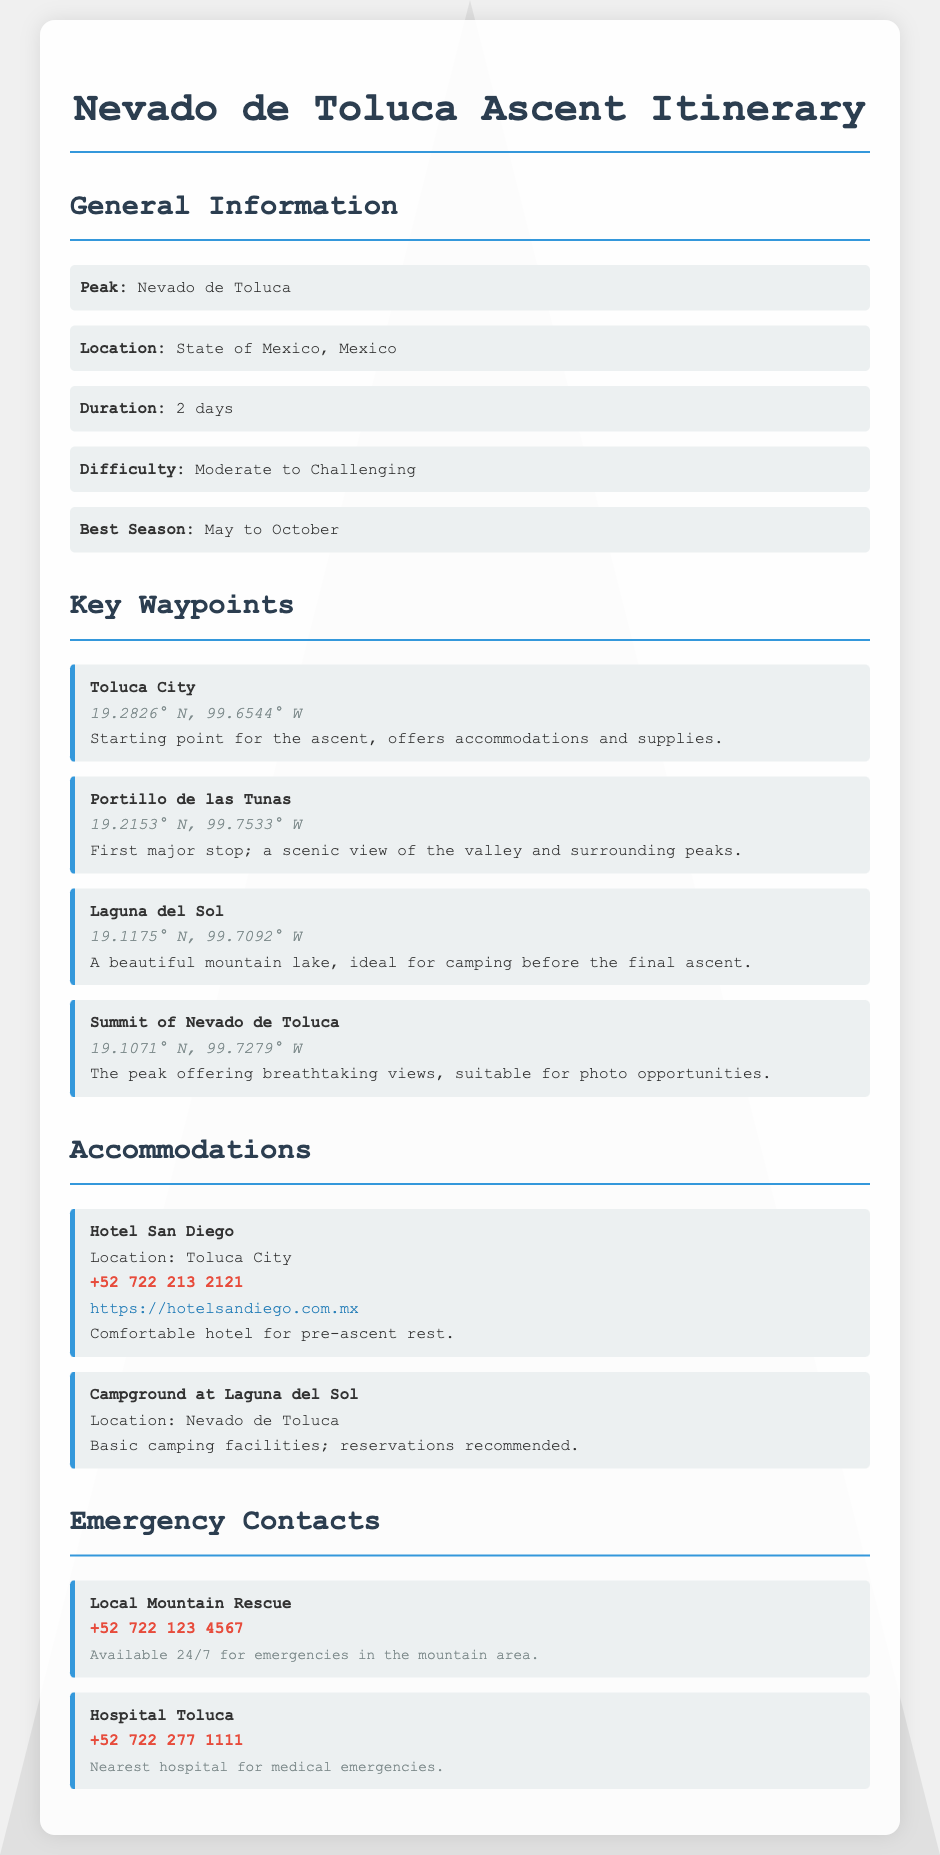What is the peak name? The peak name is mentioned in the general information section of the document.
Answer: Nevado de Toluca Where is the location of the ascent? The location is provided in the general information section and indicates the specific region.
Answer: State of Mexico, Mexico What is the difficulty level of the ascent? The difficulty level is stated in the general information section, categorizing the expected challenge for climbers.
Answer: Moderate to Challenging What is the phone number for the Hotel San Diego? The phone number for accommodations is specifically listed under the accommodations section of the document.
Answer: +52 722 213 2121 What is the coordinates of Laguna del Sol? The coordinates of this waypoint can be found listed under the key waypoints section of the document.
Answer: 19.1175° N, 99.7092° W What is the best season for the ascent? The best season is specified in the general information section for optimal climbing conditions.
Answer: May to October What type of facility is available at Laguna del Sol? The type of facility is described under accommodations within the document, detailing what climbers can expect.
Answer: Basic camping facilities Who can you contact for mountain emergencies? The emergency contacts section provides the service available for climbers in urgent situations.
Answer: Local Mountain Rescue What is the nearest hospital for emergencies? The nearest hospital is identified in the emergency contacts section of the document.
Answer: Hospital Toluca How many days is the ascent planned for? The planned duration for the ascent is mentioned in the general information section of the document.
Answer: 2 days 